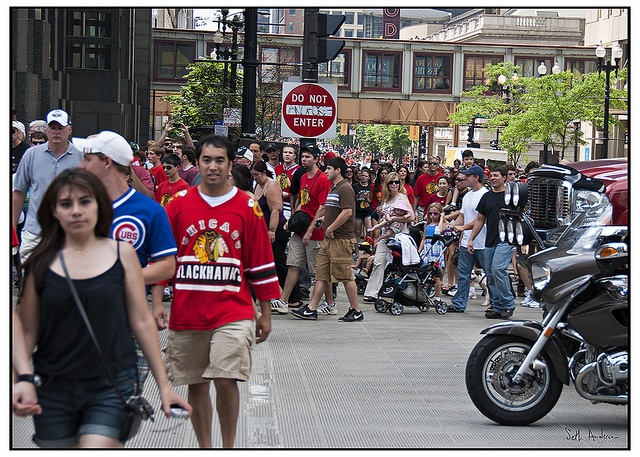Extract all visible text content from this image. DO NOT ENTER LACKHAWK UBS HICACS 